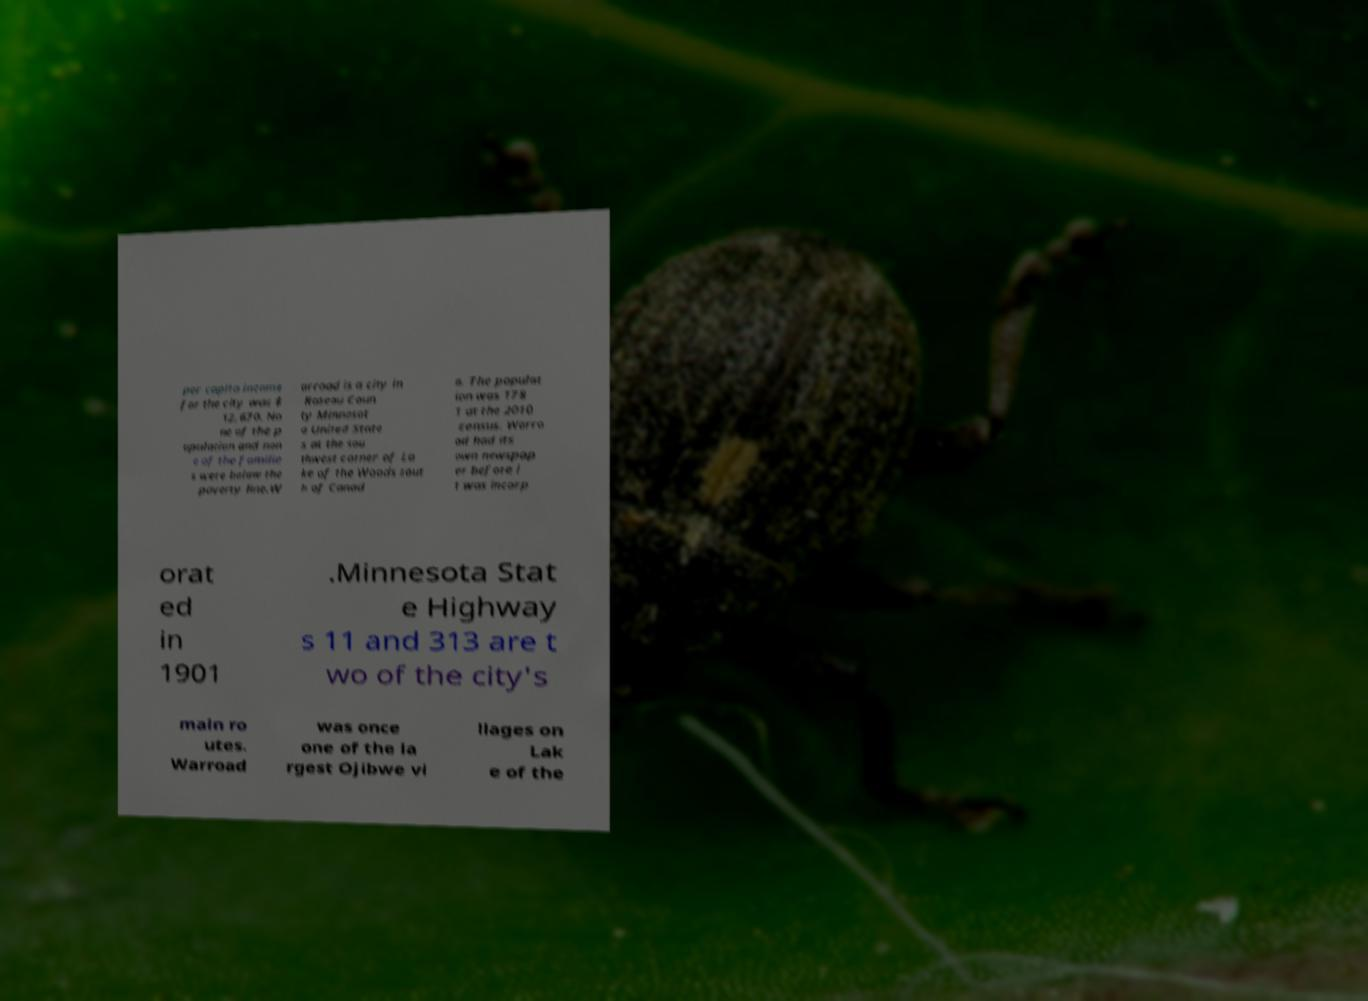Can you accurately transcribe the text from the provided image for me? per capita income for the city was $ 12,670. No ne of the p opulation and non e of the familie s were below the poverty line.W arroad is a city in Roseau Coun ty Minnesot a United State s at the sou thwest corner of La ke of the Woods sout h of Canad a. The populat ion was 178 1 at the 2010 census. Warro ad had its own newspap er before i t was incorp orat ed in 1901 .Minnesota Stat e Highway s 11 and 313 are t wo of the city's main ro utes. Warroad was once one of the la rgest Ojibwe vi llages on Lak e of the 